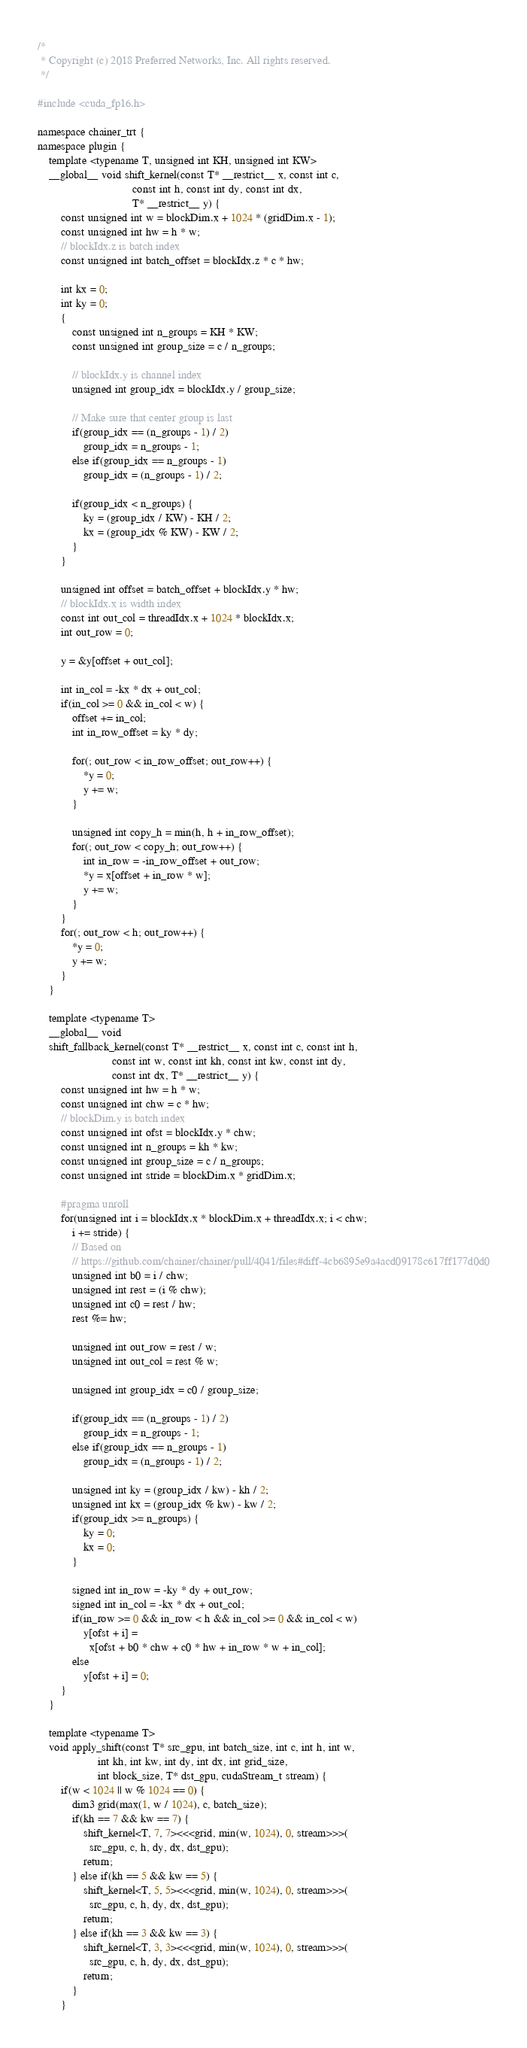Convert code to text. <code><loc_0><loc_0><loc_500><loc_500><_Cuda_>/*
 * Copyright (c) 2018 Preferred Networks, Inc. All rights reserved.
 */

#include <cuda_fp16.h>

namespace chainer_trt {
namespace plugin {
    template <typename T, unsigned int KH, unsigned int KW>
    __global__ void shift_kernel(const T* __restrict__ x, const int c,
                                 const int h, const int dy, const int dx,
                                 T* __restrict__ y) {
        const unsigned int w = blockDim.x + 1024 * (gridDim.x - 1);
        const unsigned int hw = h * w;
        // blockIdx.z is batch index
        const unsigned int batch_offset = blockIdx.z * c * hw;

        int kx = 0;
        int ky = 0;
        {
            const unsigned int n_groups = KH * KW;
            const unsigned int group_size = c / n_groups;

            // blockIdx.y is channel index
            unsigned int group_idx = blockIdx.y / group_size;

            // Make sure that center group is last
            if(group_idx == (n_groups - 1) / 2)
                group_idx = n_groups - 1;
            else if(group_idx == n_groups - 1)
                group_idx = (n_groups - 1) / 2;

            if(group_idx < n_groups) {
                ky = (group_idx / KW) - KH / 2;
                kx = (group_idx % KW) - KW / 2;
            }
        }

        unsigned int offset = batch_offset + blockIdx.y * hw;
        // blockIdx.x is width index
        const int out_col = threadIdx.x + 1024 * blockIdx.x;
        int out_row = 0;

        y = &y[offset + out_col];

        int in_col = -kx * dx + out_col;
        if(in_col >= 0 && in_col < w) {
            offset += in_col;
            int in_row_offset = ky * dy;

            for(; out_row < in_row_offset; out_row++) {
                *y = 0;
                y += w;
            }

            unsigned int copy_h = min(h, h + in_row_offset);
            for(; out_row < copy_h; out_row++) {
                int in_row = -in_row_offset + out_row;
                *y = x[offset + in_row * w];
                y += w;
            }
        }
        for(; out_row < h; out_row++) {
            *y = 0;
            y += w;
        }
    }

    template <typename T>
    __global__ void
    shift_fallback_kernel(const T* __restrict__ x, const int c, const int h,
                          const int w, const int kh, const int kw, const int dy,
                          const int dx, T* __restrict__ y) {
        const unsigned int hw = h * w;
        const unsigned int chw = c * hw;
        // blockDim.y is batch index
        const unsigned int ofst = blockIdx.y * chw;
        const unsigned int n_groups = kh * kw;
        const unsigned int group_size = c / n_groups;
        const unsigned int stride = blockDim.x * gridDim.x;

        #pragma unroll
        for(unsigned int i = blockIdx.x * blockDim.x + threadIdx.x; i < chw;
            i += stride) {
            // Based on
            // https://github.com/chainer/chainer/pull/4041/files#diff-4cb6895e9a4acd09178c617ff177d0d0
            unsigned int b0 = i / chw;
            unsigned int rest = (i % chw);
            unsigned int c0 = rest / hw;
            rest %= hw;

            unsigned int out_row = rest / w;
            unsigned int out_col = rest % w;

            unsigned int group_idx = c0 / group_size;

            if(group_idx == (n_groups - 1) / 2)
                group_idx = n_groups - 1;
            else if(group_idx == n_groups - 1)
                group_idx = (n_groups - 1) / 2;

            unsigned int ky = (group_idx / kw) - kh / 2;
            unsigned int kx = (group_idx % kw) - kw / 2;
            if(group_idx >= n_groups) {
                ky = 0;
                kx = 0;
            }

            signed int in_row = -ky * dy + out_row;
            signed int in_col = -kx * dx + out_col;
            if(in_row >= 0 && in_row < h && in_col >= 0 && in_col < w)
                y[ofst + i] =
                  x[ofst + b0 * chw + c0 * hw + in_row * w + in_col];
            else
                y[ofst + i] = 0;
        }
    }

    template <typename T>
    void apply_shift(const T* src_gpu, int batch_size, int c, int h, int w,
                     int kh, int kw, int dy, int dx, int grid_size,
                     int block_size, T* dst_gpu, cudaStream_t stream) {
        if(w < 1024 || w % 1024 == 0) {
            dim3 grid(max(1, w / 1024), c, batch_size);
            if(kh == 7 && kw == 7) {
                shift_kernel<T, 7, 7><<<grid, min(w, 1024), 0, stream>>>(
                  src_gpu, c, h, dy, dx, dst_gpu);
                return;
            } else if(kh == 5 && kw == 5) {
                shift_kernel<T, 5, 5><<<grid, min(w, 1024), 0, stream>>>(
                  src_gpu, c, h, dy, dx, dst_gpu);
                return;
            } else if(kh == 3 && kw == 3) {
                shift_kernel<T, 3, 3><<<grid, min(w, 1024), 0, stream>>>(
                  src_gpu, c, h, dy, dx, dst_gpu);
                return;
            }
        }
</code> 